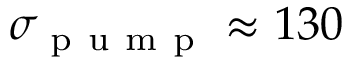Convert formula to latex. <formula><loc_0><loc_0><loc_500><loc_500>\sigma _ { p u m p } \approx 1 3 0</formula> 